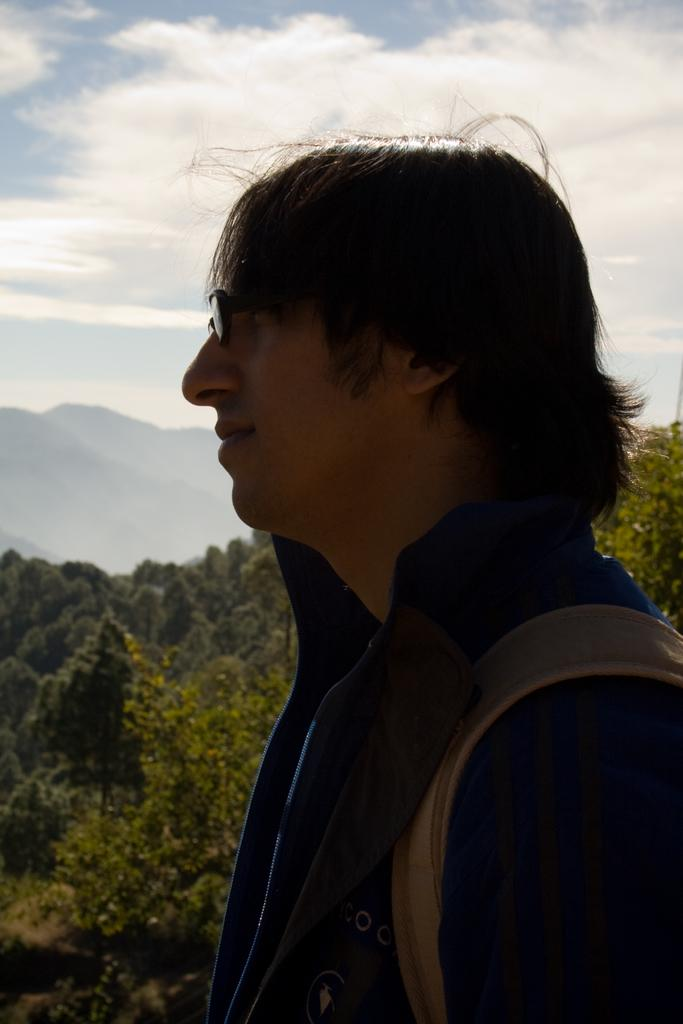Who is the main subject in the image? There is a man in the image. What can be seen behind the man? There are trees behind the man. What type of landscape is visible in the image? There are hills visible in the image. What is visible above the man and the trees? The sky is visible in the image. What type of story is the fireman telling in the image? There is no fireman present in the image, and therefore no story can be observed. 